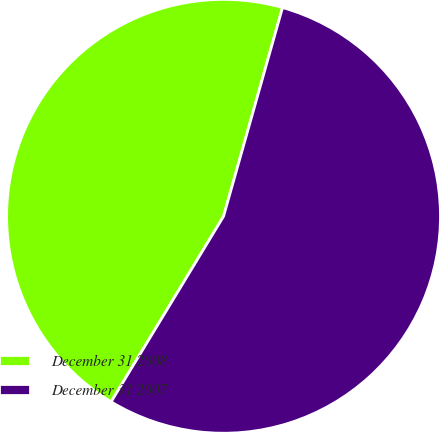Convert chart. <chart><loc_0><loc_0><loc_500><loc_500><pie_chart><fcel>December 31 2008<fcel>December 31 2007<nl><fcel>45.71%<fcel>54.29%<nl></chart> 